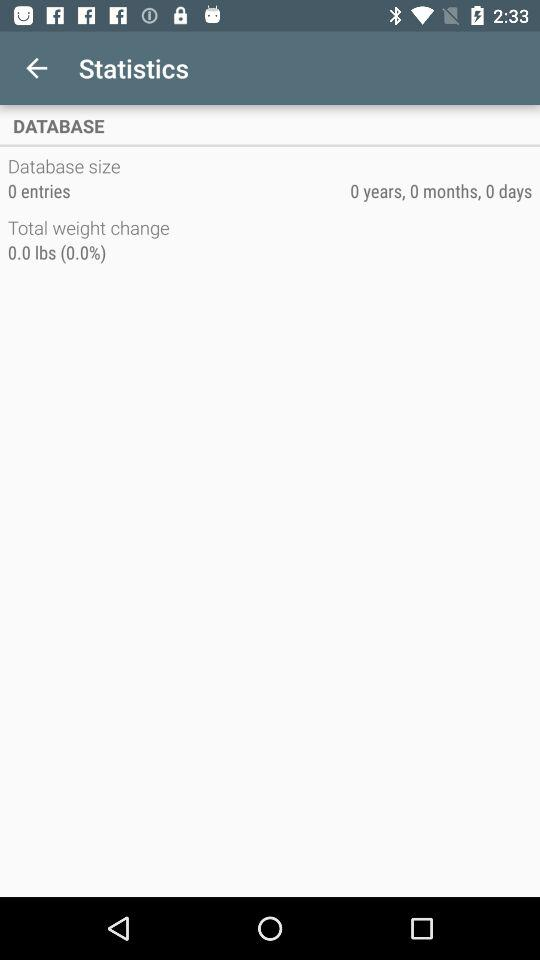What is the change in total weight? The change in total weight is 0.0 lbs. 